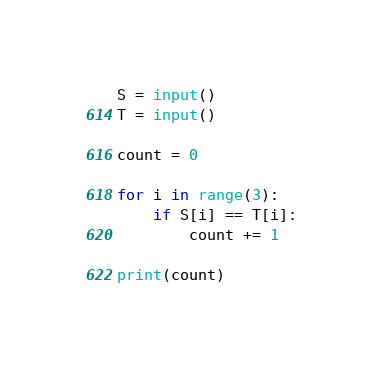<code> <loc_0><loc_0><loc_500><loc_500><_Python_>S = input()
T = input()

count = 0

for i in range(3):
    if S[i] == T[i]:
        count += 1
        
print(count)</code> 